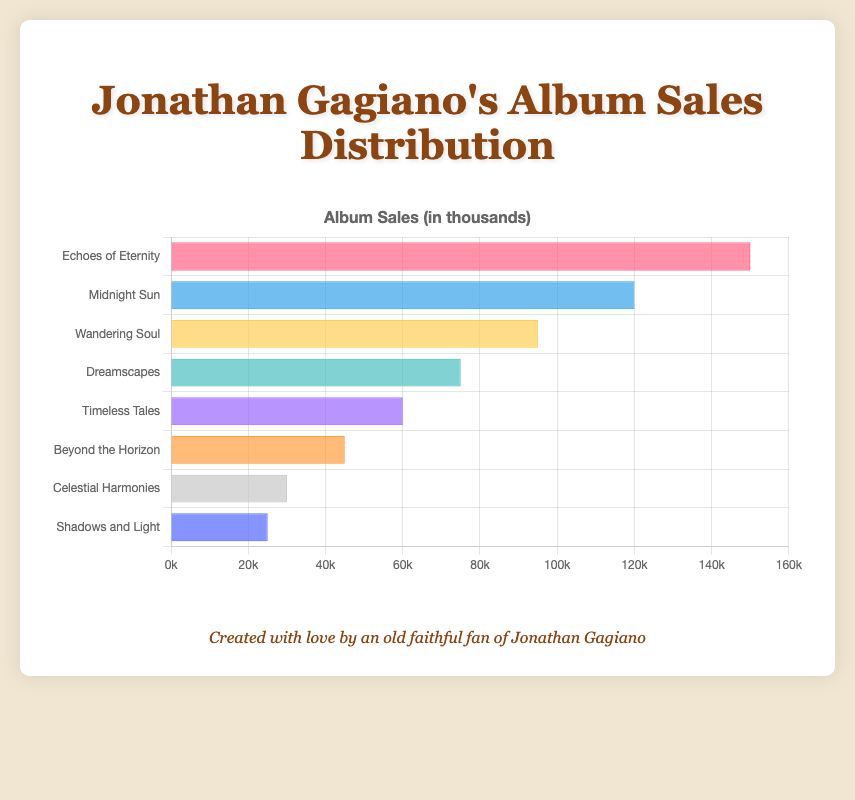Which album has the highest sales? Look at the bar with the greatest length; it represents the album with the highest sales. "Echoes of Eternity" has the longest bar, which indicates the highest sales.
Answer: Echoes of Eternity Which album has more sales, "Midnight Sun" or "Dreamscapes"? Compare the lengths of the bars for "Midnight Sun" and "Dreamscapes". "Midnight Sun" has a longer bar compared to "Dreamscapes", indicating higher sales.
Answer: Midnight Sun What is the total sales of "Wandering Soul" and "Beyond the Horizon"? Add the sales figures for "Wandering Soul" (95,000) and "Beyond the Horizon" (45,000): 95,000 + 45,000 = 140,000
Answer: 140,000 Which album has the least sales? Identify the bar with the smallest length; it indicates the album with the least sales. "Shadows and Light" has the shortest bar.
Answer: Shadows and Light How much more sales does "Timeless Tales" have compared to "Celestial Harmonies"? Subtract the sales of "Celestial Harmonies" from "Timeless Tales": 60,000 - 30,000 = 30,000
Answer: 30,000 Which albums have sales greater than 100,000? Look at the bars that extend beyond the 100,000 sales mark. Only "Echoes of Eternity" and "Midnight Sun" meet this criterion.
Answer: Echoes of Eternity, Midnight Sun What is the average sales of the albums? Add up all the sales figures, then divide by the number of albums: (150,000 + 120,000 + 95,000 + 75,000 + 60,000 + 45,000 + 30,000 + 25,000) / 8 = 600,000 / 8 = 75,000
Answer: 75,000 Which album sales are closest to the average sales? Calculate the distance of each album's sales to the average sales of 75,000, and find the smallest distance. "Dreamscapes" has sales of 75,000, which exactly matches the average.
Answer: Dreamscapes Arrange the albums in descending order of sales. Order the album bars from longest to shortest: "Echoes of Eternity", "Midnight Sun", "Wandering Soul", "Dreamscapes", "Timeless Tales", "Beyond the Horizon", "Celestial Harmonies", "Shadows and Light".
Answer: Echoes of Eternity, Midnight Sun, Wandering Soul, Dreamscapes, Timeless Tales, Beyond the Horizon, Celestial Harmonies, Shadows and Light By how much do the sales of "Echoes of Eternity" exceed those of the album with the lowest sales? Subtract the sales of the album with the smallest sales ("Shadows and Light", 25,000) from "Echoes of Eternity" (150,000): 150,000 - 25,000 = 125,000
Answer: 125,000 